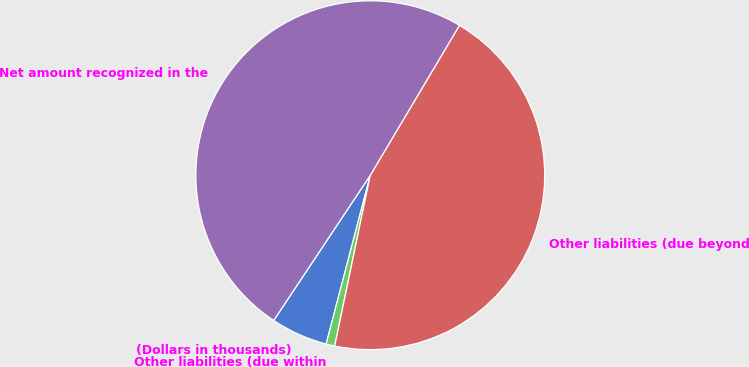Convert chart to OTSL. <chart><loc_0><loc_0><loc_500><loc_500><pie_chart><fcel>(Dollars in thousands)<fcel>Other liabilities (due within<fcel>Other liabilities (due beyond<fcel>Net amount recognized in the<nl><fcel>5.27%<fcel>0.8%<fcel>44.73%<fcel>49.2%<nl></chart> 